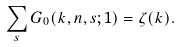Convert formula to latex. <formula><loc_0><loc_0><loc_500><loc_500>\sum _ { s } G _ { 0 } ( k , n , s ; 1 ) = \zeta ( k ) .</formula> 